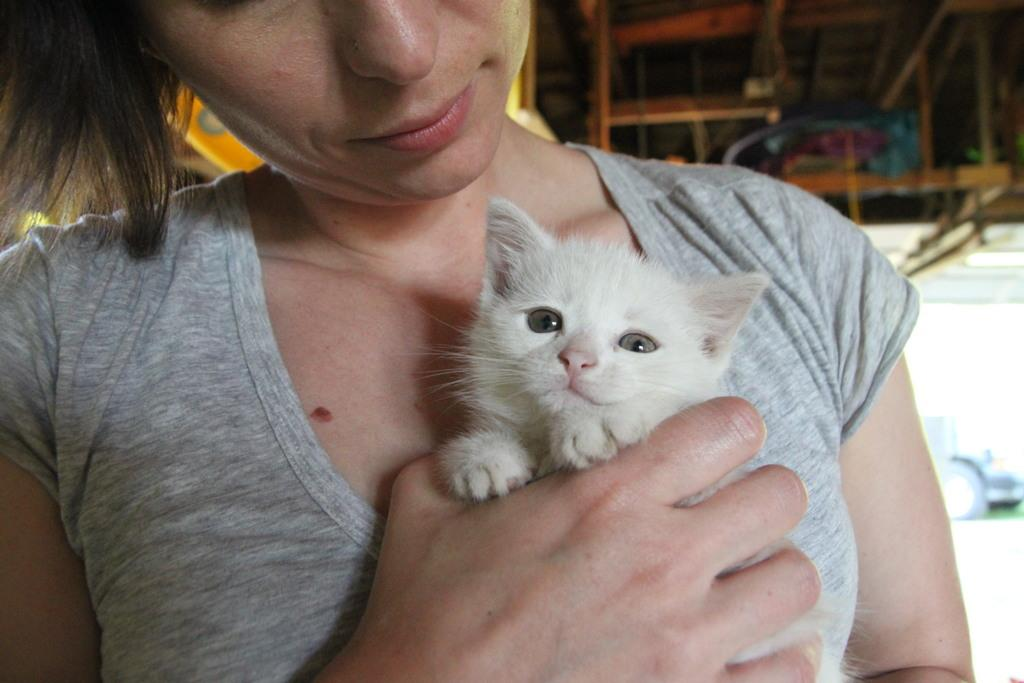What is the person in the image doing? The person is holding a cat in the image. Can you describe the cat in the image? The cat is white. What is the person wearing in the image? The person is wearing a gray shirt. What can be seen in the background of the image? There is a wooden object in the background of the image. What type of prison is visible in the image? There is no prison present in the image. How many firemen are visible in the image? There are no firemen present in the image. 